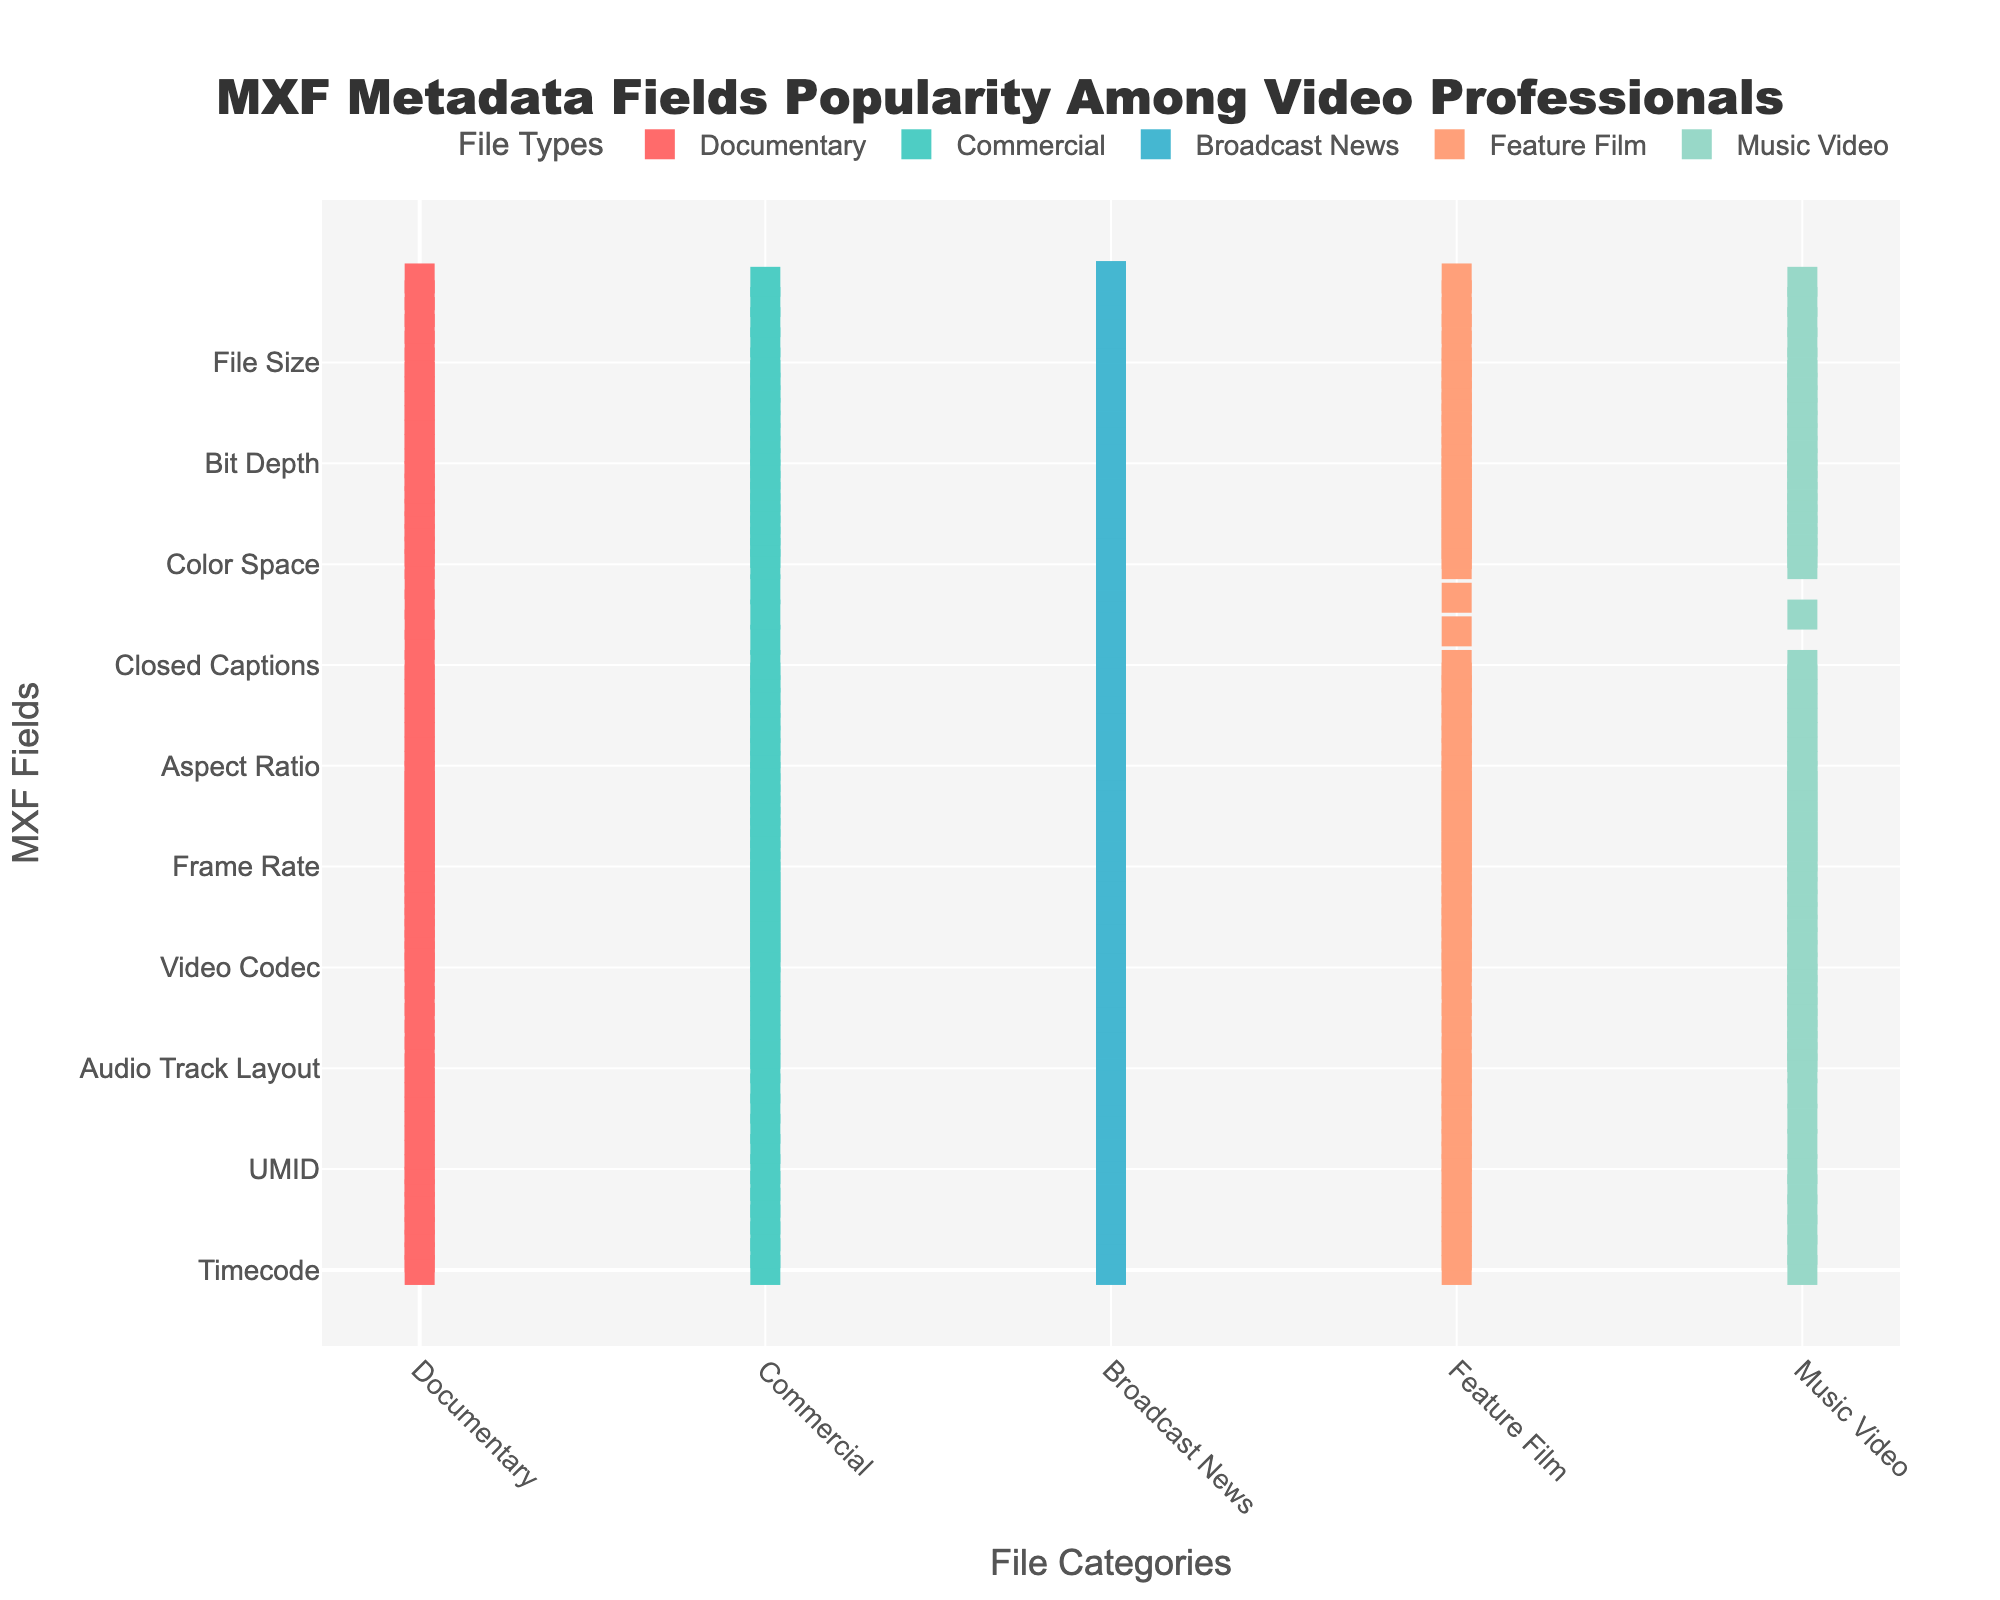What is the most popular MXF metadata field among Feature Films? The highest value for Feature Films should be identified. The data shows that for Feature Films, Frame Rate has the highest popularity with a score of 10.
Answer: Frame Rate Which file category has the least amount of popularity for Closed Captions? The lowest value for Closed Captions across all file categories should be identified. The data indicates that Music Video, with a score of 2, has the least popularity for Closed Captions.
Answer: Music Video How many file categories have a score of 10 for Frame Rate? By examining the values for Frame Rate across all file categories, count the instances where the score is 10. The data shows that Frame Rate is scored 10 in 4 file categories (Documentary, Broadcast News, Feature Film, and Music Video).
Answer: 4 Which MXF metadata field holds the second lowest popularity for Commercials? Sort the values for Commercials to determine the second lowest score. Audio Track Layout and File Size both have a score of 5, but the prompt specified the second lowest, which is Timecode with a score of 6.
Answer: Timecode What is the combined popularity score of Bit Depth across all file categories? Sum the values of Bit Depth for all file categories. The data shows the scores are 7, 8, 6, 9, 8 which add up to 38.
Answer: 38 Does Broadcast News have a higher popularity score for Color Space or for Aspect Ratio? Compare the values for Color Space and Aspect Ratio in Broadcast News. Color Space has a score of 5 while Aspect Ratio has a score of 6. Therefore, Aspect Ratio is higher.
Answer: Aspect Ratio Which MXF metadata field has the highest popularity score across all file categories? Review all values to identify the maximum score appearing in the data set. Frame Rate has the multiple highest occurrences of 10 in different categories (Documentary, Broadcast News, Feature Film, and Music Video).
Answer: Frame Rate In which file category does Audio Track Layout hold the highest score? By identifying the highest value for Audio Track Layout across the file categories, Music Video is seen with the highest score of 9.
Answer: Music Video What is the average popularity score of Video Codec across all file categories? Average values for Video Codec should be calculated by summing them and dividing by the number of categories. The scores are 9, 10, 7, 9, 8 which sum to 43, divided by 5 equals 8.6.
Answer: 8.6 